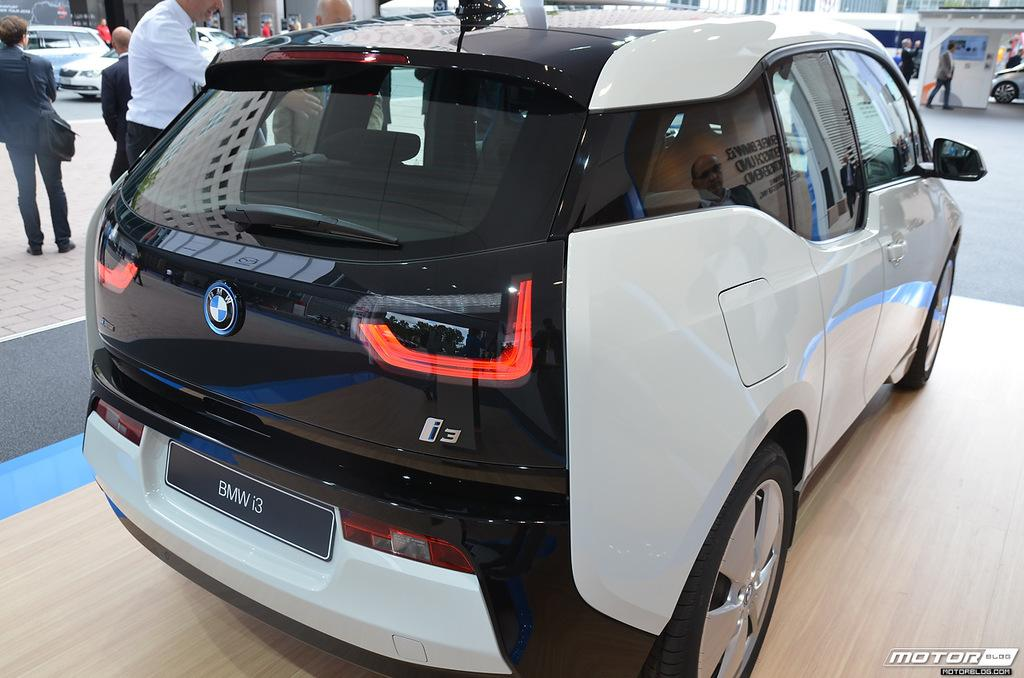What is the main subject of the picture? The main subject of the picture is a car. What features can be seen on the car? The car has lights and a logo. What is happening on the left side of the car? There are people standing on the left side of the car. What can be seen in the background on the right side of the car? There is a building in the backdrop on the right side of the car. Can you tell me how many goldfish are swimming in the car's logo? There are no goldfish present in the image, and the car's logo does not depict any goldfish. What type of hand is holding the car in the image? There is no hand holding the car in the image; it is stationary on the ground. 